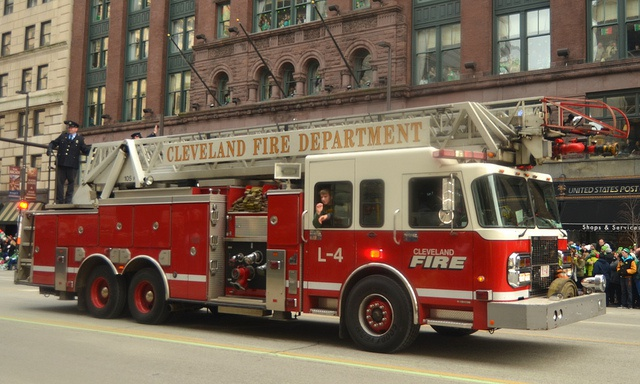Describe the objects in this image and their specific colors. I can see truck in tan, black, and maroon tones, people in tan, black, and gray tones, people in tan, black, gray, brown, and maroon tones, people in tan, black, maroon, and brown tones, and people in tan, black, navy, gray, and darkblue tones in this image. 